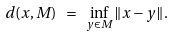<formula> <loc_0><loc_0><loc_500><loc_500>d ( x , M ) \ = \ \inf _ { y \in M } \| x - y \| .</formula> 